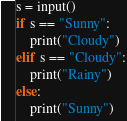<code> <loc_0><loc_0><loc_500><loc_500><_Python_>s = input()
if s == "Sunny":
	print("Cloudy")
elif s == "Cloudy":
	print("Rainy")
else:
	print("Sunny")</code> 